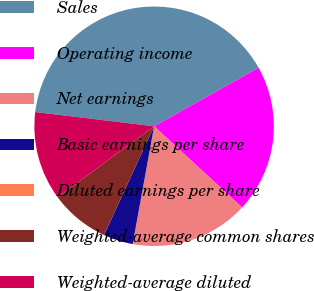<chart> <loc_0><loc_0><loc_500><loc_500><pie_chart><fcel>Sales<fcel>Operating income<fcel>Net earnings<fcel>Basic earnings per share<fcel>Diluted earnings per share<fcel>Weighted-average common shares<fcel>Weighted-average diluted<nl><fcel>39.97%<fcel>19.99%<fcel>16.0%<fcel>4.01%<fcel>0.01%<fcel>8.01%<fcel>12.0%<nl></chart> 